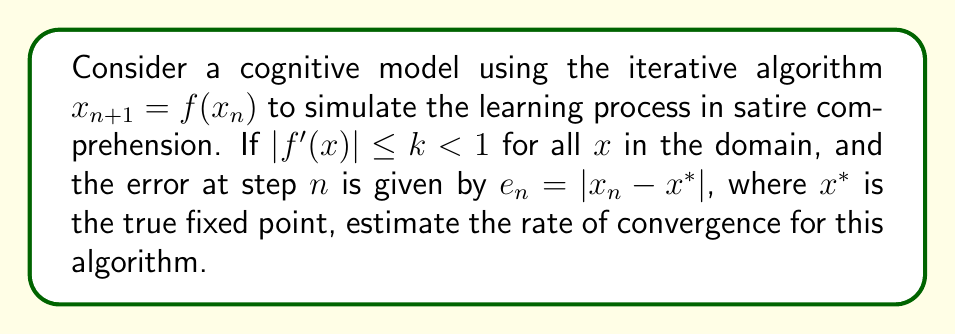Help me with this question. 1. For iterative algorithms of the form $x_{n+1} = f(x_n)$, the rate of convergence is determined by the derivative of $f(x)$ at the fixed point $x^*$.

2. Given that $|f'(x)| \leq k < 1$ for all $x$ in the domain, we can use this as an upper bound for the rate of convergence.

3. The error at step $n+1$ can be expressed as:
   $$e_{n+1} = |x_{n+1} - x^*| = |f(x_n) - f(x^*)|$$

4. Using the Mean Value Theorem, we can write:
   $$|f(x_n) - f(x^*)| = |f'(\xi)| \cdot |x_n - x^*|$$
   where $\xi$ is some point between $x_n$ and $x^*$.

5. Since $|f'(x)| \leq k < 1$ for all $x$, we can say:
   $$e_{n+1} \leq k \cdot e_n$$

6. This inequality shows that the error decreases by at least a factor of $k$ at each iteration.

7. The rate of convergence for this type of convergence (linear convergence) is typically expressed as:
   $$\lim_{n \to \infty} \frac{e_{n+1}}{e_n} \leq k$$

8. Therefore, the rate of convergence for this iterative algorithm is at most $k$, where $k$ is the upper bound of $|f'(x)|$.
Answer: $k$ 